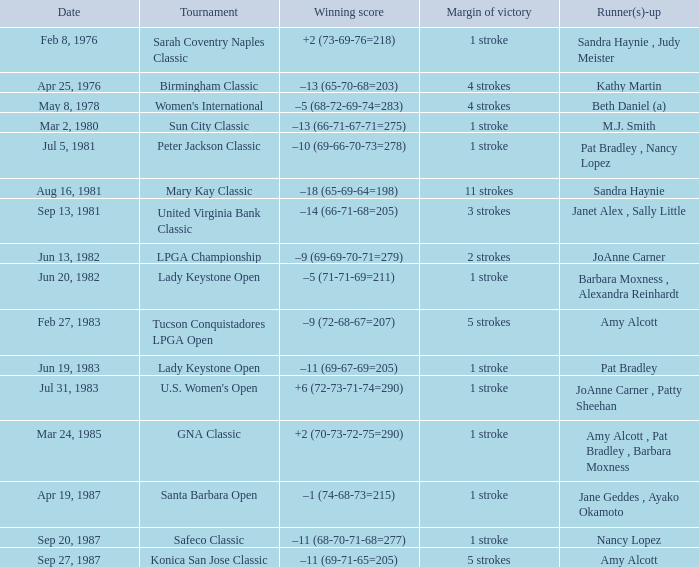What is the margin of victory when the tournament is konica san jose classic? 5 strokes. 